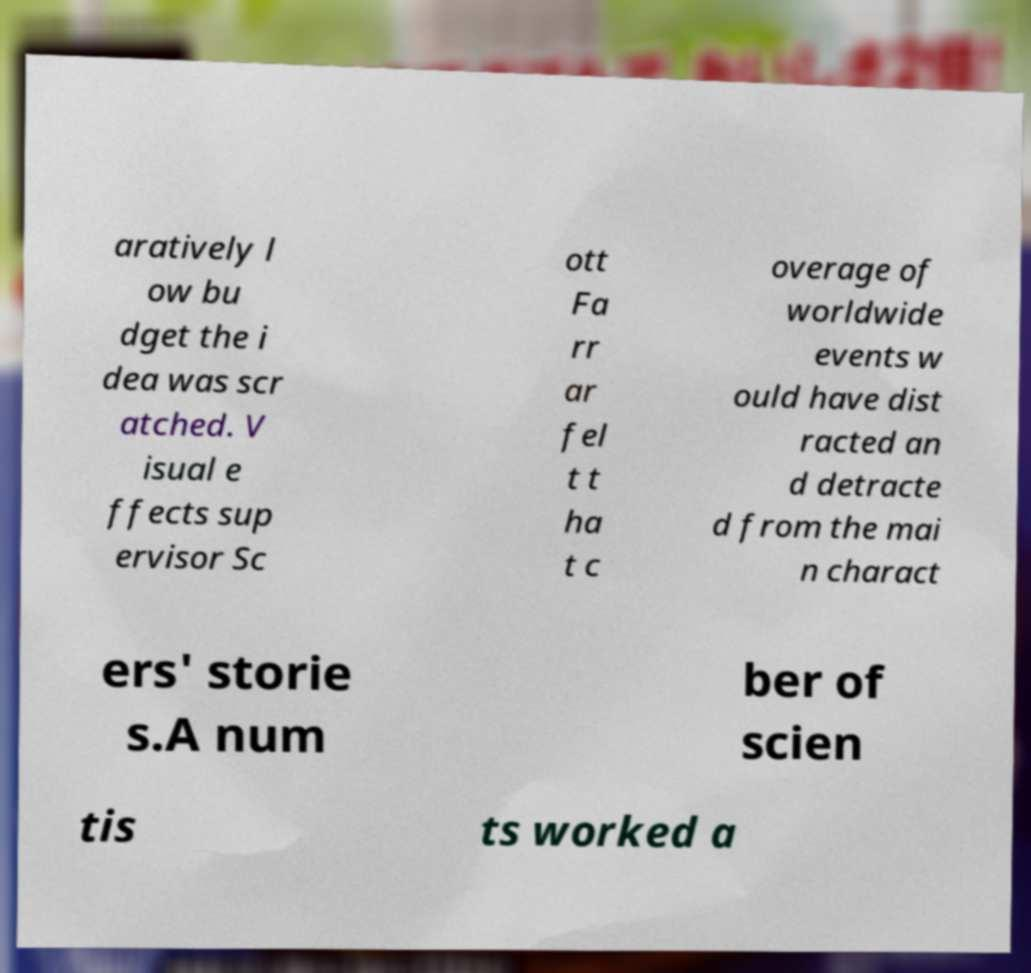Please identify and transcribe the text found in this image. aratively l ow bu dget the i dea was scr atched. V isual e ffects sup ervisor Sc ott Fa rr ar fel t t ha t c overage of worldwide events w ould have dist racted an d detracte d from the mai n charact ers' storie s.A num ber of scien tis ts worked a 